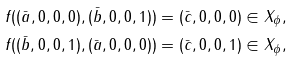Convert formula to latex. <formula><loc_0><loc_0><loc_500><loc_500>f ( ( \bar { a } , 0 , 0 , 0 ) , ( \bar { b } , 0 , 0 , 1 ) ) & = ( \bar { c } , 0 , 0 , 0 ) \in X _ { \phi } , \\ f ( ( \bar { b } , 0 , 0 , 1 ) , ( \bar { a } , 0 , 0 , 0 ) ) & = ( \bar { c } , 0 , 0 , 1 ) \in X _ { \phi } ,</formula> 